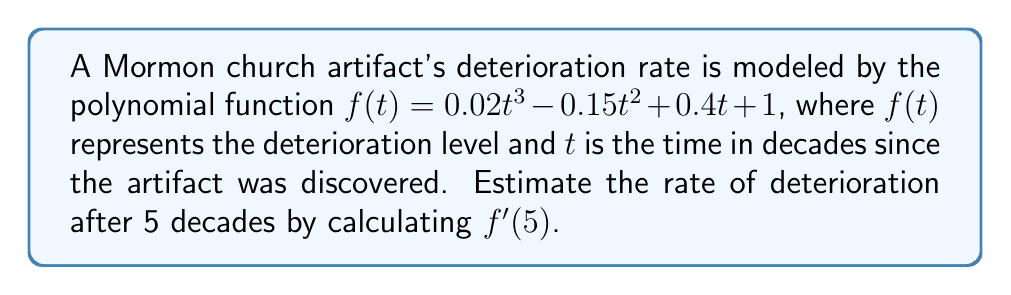Teach me how to tackle this problem. To estimate the rate of deterioration after 5 decades, we need to find $f'(5)$. Let's approach this step-by-step:

1) First, we need to find the derivative of $f(t)$:
   $f(t) = 0.02t^3 - 0.15t^2 + 0.4t + 1$
   $f'(t) = 0.06t^2 - 0.3t + 0.4$

2) Now that we have $f'(t)$, we can calculate $f'(5)$ by substituting $t=5$:
   $f'(5) = 0.06(5^2) - 0.3(5) + 0.4$

3) Let's evaluate each term:
   $0.06(5^2) = 0.06(25) = 1.5$
   $-0.3(5) = -1.5$
   $0.4$ remains as is

4) Now we can add these terms:
   $f'(5) = 1.5 - 1.5 + 0.4 = 0.4$

Therefore, the estimated rate of deterioration after 5 decades is 0.4 units per decade.
Answer: 0.4 units per decade 